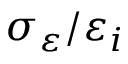<formula> <loc_0><loc_0><loc_500><loc_500>\sigma _ { \varepsilon } / \varepsilon _ { i }</formula> 